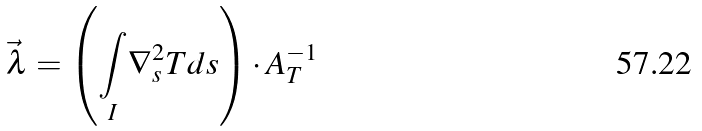Convert formula to latex. <formula><loc_0><loc_0><loc_500><loc_500>\vec { \lambda } = \left ( \underset { I } { \int } \nabla _ { s } ^ { 2 } T d s \right ) \cdot A _ { T } ^ { - 1 }</formula> 